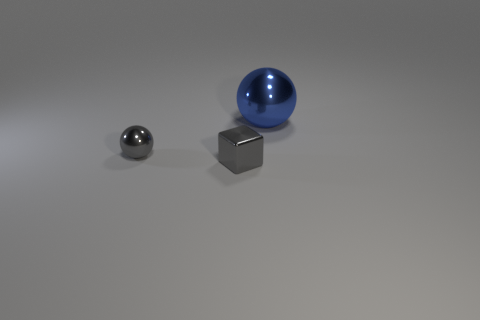Is there any other thing that has the same size as the blue metal sphere?
Keep it short and to the point. No. Are there fewer blue objects than yellow metal things?
Keep it short and to the point. No. There is a object on the left side of the tiny metallic cube; is its size the same as the gray block that is right of the gray ball?
Provide a short and direct response. Yes. What number of objects are either tiny gray shiny things or big red metallic cubes?
Provide a succinct answer. 2. There is a metallic sphere on the left side of the blue metal object; what size is it?
Your answer should be very brief. Small. How many metal objects are in front of the tiny gray metallic thing in front of the sphere that is in front of the big object?
Ensure brevity in your answer.  0. Is the color of the block the same as the small metal sphere?
Give a very brief answer. Yes. What number of shiny objects are both to the right of the small shiny sphere and in front of the blue thing?
Offer a very short reply. 1. What is the shape of the tiny thing that is left of the tiny gray shiny cube?
Ensure brevity in your answer.  Sphere. Are there fewer tiny cubes that are right of the tiny block than big metallic spheres on the right side of the large blue ball?
Make the answer very short. No. 